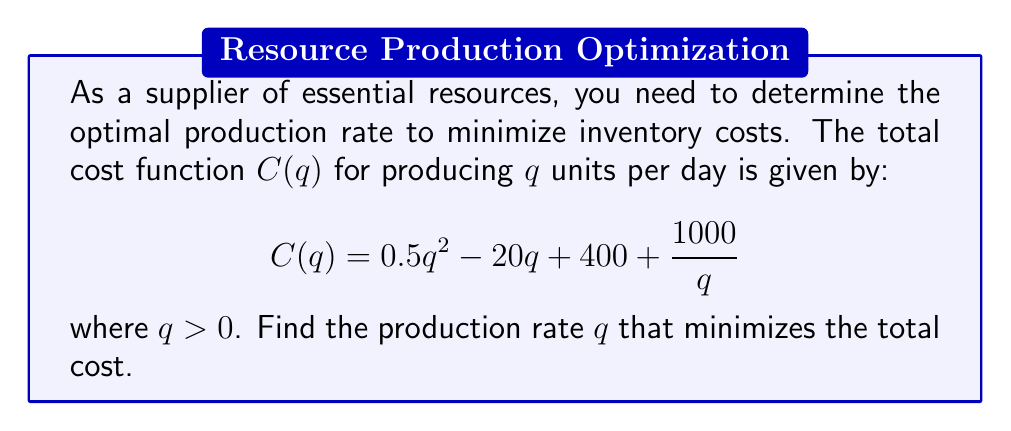What is the answer to this math problem? To find the minimum of the cost function, we need to find the value of $q$ where the derivative of $C(q)$ equals zero.

Step 1: Calculate the derivative of $C(q)$
$$C'(q) = \frac{d}{dq}(0.5q^2 - 20q + 400 + \frac{1000}{q})$$
$$C'(q) = q - 20 - \frac{1000}{q^2}$$

Step 2: Set the derivative equal to zero and solve for $q$
$$q - 20 - \frac{1000}{q^2} = 0$$
$$q^3 - 20q^2 - 1000 = 0$$

Step 3: This is a cubic equation. We can solve it by factoring or using the cubic formula. By factoring, we get:
$$(q - 25)(q^2 + 5q + 40) = 0$$

Step 4: Solve the equation
$q - 25 = 0$ or $q^2 + 5q + 40 = 0$
$q = 25$ or $q = -8$ or $q = -5$

Step 5: Since $q$ represents a production rate, it must be positive. Therefore, the only valid solution is $q = 25$.

Step 6: Verify that this is a minimum by checking the second derivative
$$C''(q) = 1 + \frac{2000}{q^3}$$
At $q = 25$, $C''(25) = 1 + \frac{2000}{25^3} > 0$, confirming it's a minimum.
Answer: 25 units per day 